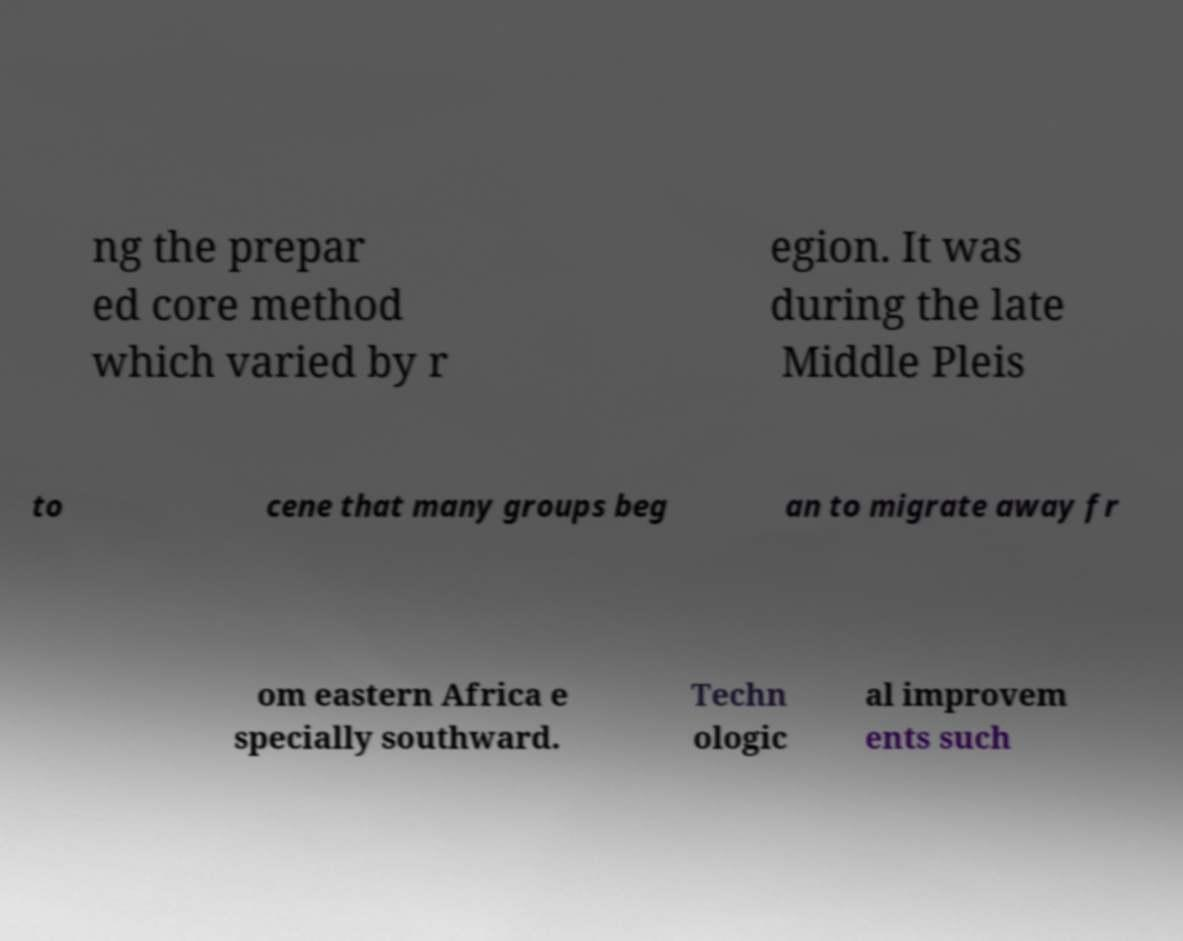Can you read and provide the text displayed in the image?This photo seems to have some interesting text. Can you extract and type it out for me? ng the prepar ed core method which varied by r egion. It was during the late Middle Pleis to cene that many groups beg an to migrate away fr om eastern Africa e specially southward. Techn ologic al improvem ents such 